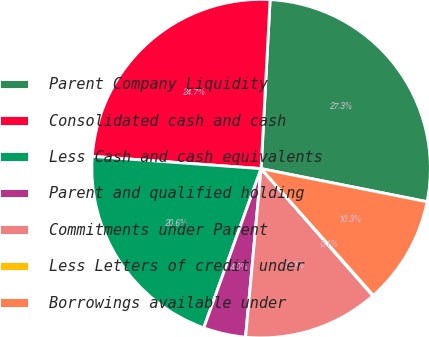<chart> <loc_0><loc_0><loc_500><loc_500><pie_chart><fcel>Parent Company Liquidity<fcel>Consolidated cash and cash<fcel>Less Cash and cash equivalents<fcel>Parent and qualified holding<fcel>Commitments under Parent<fcel>Less Letters of credit under<fcel>Borrowings available under<nl><fcel>27.29%<fcel>24.69%<fcel>20.65%<fcel>4.04%<fcel>12.94%<fcel>0.06%<fcel>10.33%<nl></chart> 